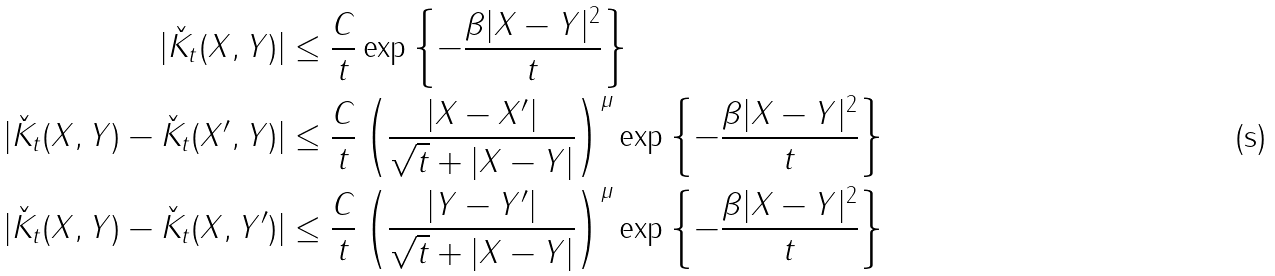<formula> <loc_0><loc_0><loc_500><loc_500>| \check { K } _ { t } ( X , Y ) | & \leq \frac { C } { t } \exp \left \{ - \frac { \beta | X - Y | ^ { 2 } } { t } \right \} \\ | \check { K } _ { t } ( X , Y ) - \check { K } _ { t } ( X ^ { \prime } , Y ) | & \leq \frac { C } { t } \left ( \frac { | X - X ^ { \prime } | } { \sqrt { t } + | X - Y | } \right ) ^ { \mu } \exp \left \{ - \frac { \beta | X - Y | ^ { 2 } } { t } \right \} \\ | \check { K } _ { t } ( X , Y ) - \check { K } _ { t } ( X , Y ^ { \prime } ) | & \leq \frac { C } { t } \left ( \frac { | Y - Y ^ { \prime } | } { \sqrt { t } + | X - Y | } \right ) ^ { \mu } \exp \left \{ - \frac { \beta | X - Y | ^ { 2 } } { t } \right \}</formula> 